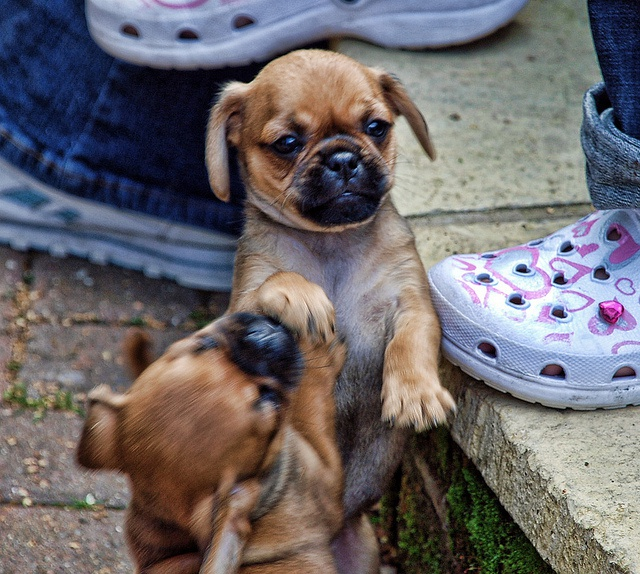Describe the objects in this image and their specific colors. I can see dog in navy, gray, black, and darkgray tones, people in navy, darkgray, lavender, and gray tones, dog in navy, gray, maroon, brown, and black tones, and people in navy, black, gray, and darkblue tones in this image. 